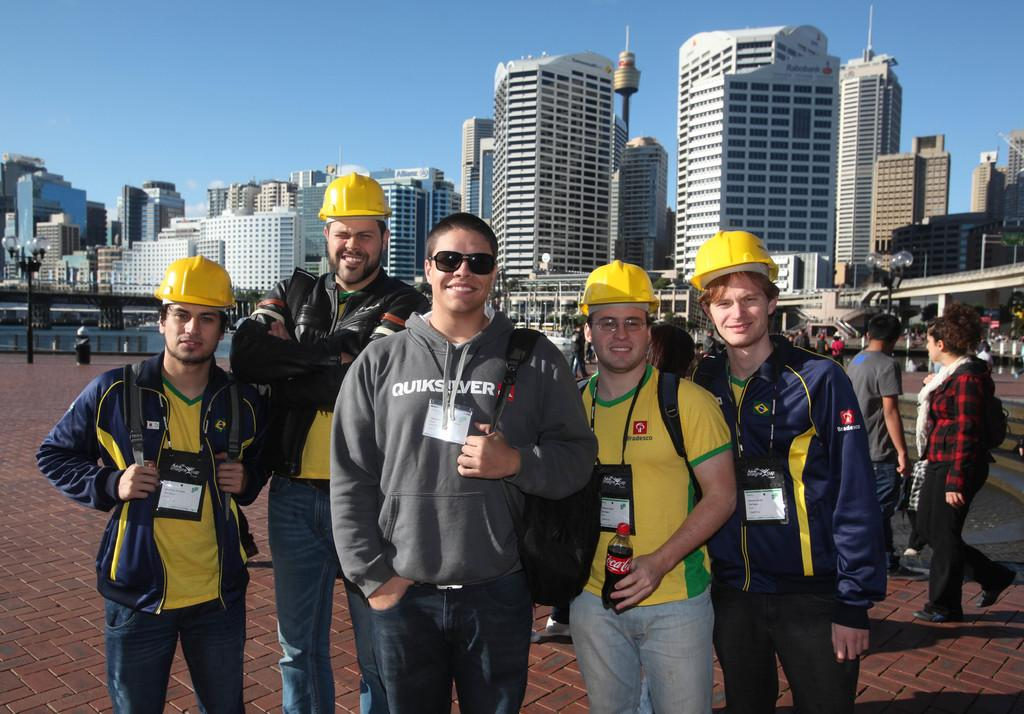What can be seen in the image in terms of human presence? There are groups of people in the image. What type of artificial light sources are present in the image? There are street lamps in the image. What type of structures can be seen in the image? There are buildings in the image. What natural element is visible in the image? There is water visible in the image. What part of the natural environment is visible in the image? The sky is visible in the image. What type of rhythm can be heard from the beggar in the image? There is no beggar present in the image, and therefore no rhythm can be heard. How many drops of water are visible in the image? The image does not specify a specific number of drops of water; it only mentions that water is visible. 